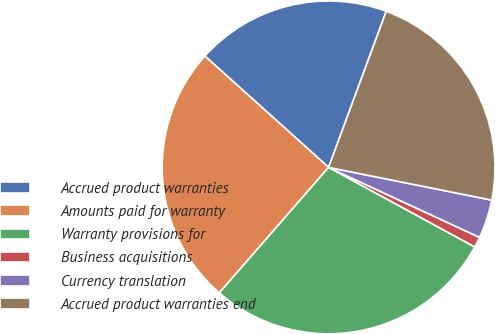<chart> <loc_0><loc_0><loc_500><loc_500><pie_chart><fcel>Accrued product warranties<fcel>Amounts paid for warranty<fcel>Warranty provisions for<fcel>Business acquisitions<fcel>Currency translation<fcel>Accrued product warranties end<nl><fcel>18.97%<fcel>25.26%<fcel>28.47%<fcel>1.02%<fcel>3.76%<fcel>22.52%<nl></chart> 